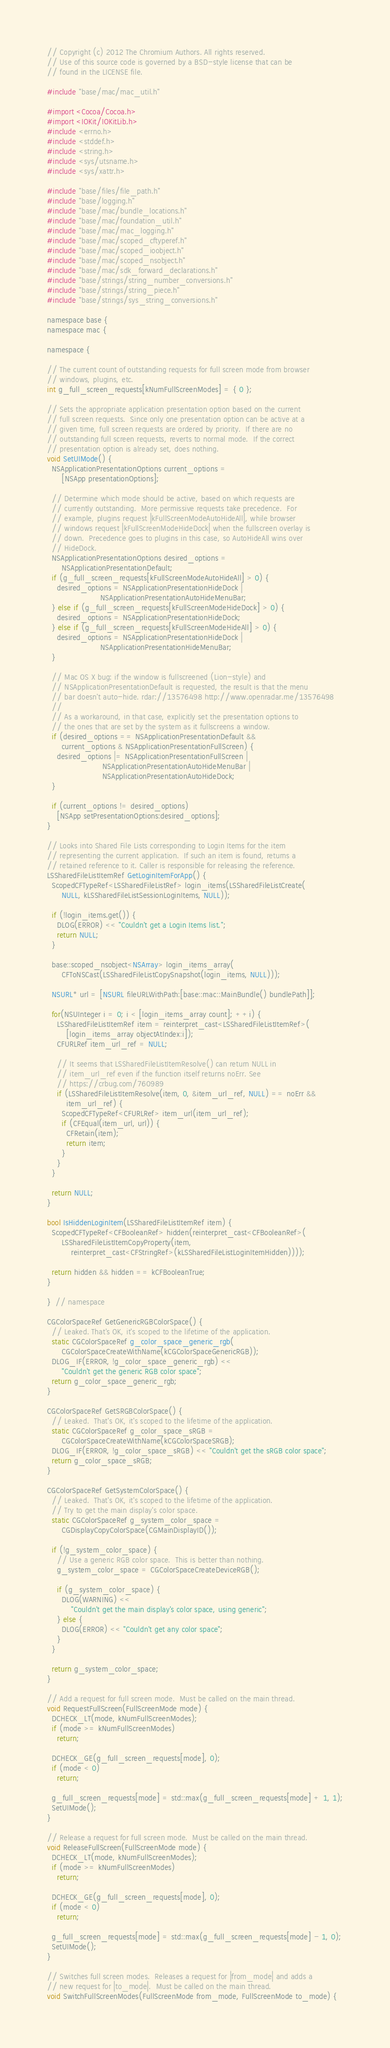Convert code to text. <code><loc_0><loc_0><loc_500><loc_500><_ObjectiveC_>// Copyright (c) 2012 The Chromium Authors. All rights reserved.
// Use of this source code is governed by a BSD-style license that can be
// found in the LICENSE file.

#include "base/mac/mac_util.h"

#import <Cocoa/Cocoa.h>
#import <IOKit/IOKitLib.h>
#include <errno.h>
#include <stddef.h>
#include <string.h>
#include <sys/utsname.h>
#include <sys/xattr.h>

#include "base/files/file_path.h"
#include "base/logging.h"
#include "base/mac/bundle_locations.h"
#include "base/mac/foundation_util.h"
#include "base/mac/mac_logging.h"
#include "base/mac/scoped_cftyperef.h"
#include "base/mac/scoped_ioobject.h"
#include "base/mac/scoped_nsobject.h"
#include "base/mac/sdk_forward_declarations.h"
#include "base/strings/string_number_conversions.h"
#include "base/strings/string_piece.h"
#include "base/strings/sys_string_conversions.h"

namespace base {
namespace mac {

namespace {

// The current count of outstanding requests for full screen mode from browser
// windows, plugins, etc.
int g_full_screen_requests[kNumFullScreenModes] = { 0 };

// Sets the appropriate application presentation option based on the current
// full screen requests.  Since only one presentation option can be active at a
// given time, full screen requests are ordered by priority.  If there are no
// outstanding full screen requests, reverts to normal mode.  If the correct
// presentation option is already set, does nothing.
void SetUIMode() {
  NSApplicationPresentationOptions current_options =
      [NSApp presentationOptions];

  // Determine which mode should be active, based on which requests are
  // currently outstanding.  More permissive requests take precedence.  For
  // example, plugins request |kFullScreenModeAutoHideAll|, while browser
  // windows request |kFullScreenModeHideDock| when the fullscreen overlay is
  // down.  Precedence goes to plugins in this case, so AutoHideAll wins over
  // HideDock.
  NSApplicationPresentationOptions desired_options =
      NSApplicationPresentationDefault;
  if (g_full_screen_requests[kFullScreenModeAutoHideAll] > 0) {
    desired_options = NSApplicationPresentationHideDock |
                      NSApplicationPresentationAutoHideMenuBar;
  } else if (g_full_screen_requests[kFullScreenModeHideDock] > 0) {
    desired_options = NSApplicationPresentationHideDock;
  } else if (g_full_screen_requests[kFullScreenModeHideAll] > 0) {
    desired_options = NSApplicationPresentationHideDock |
                      NSApplicationPresentationHideMenuBar;
  }

  // Mac OS X bug: if the window is fullscreened (Lion-style) and
  // NSApplicationPresentationDefault is requested, the result is that the menu
  // bar doesn't auto-hide. rdar://13576498 http://www.openradar.me/13576498
  //
  // As a workaround, in that case, explicitly set the presentation options to
  // the ones that are set by the system as it fullscreens a window.
  if (desired_options == NSApplicationPresentationDefault &&
      current_options & NSApplicationPresentationFullScreen) {
    desired_options |= NSApplicationPresentationFullScreen |
                       NSApplicationPresentationAutoHideMenuBar |
                       NSApplicationPresentationAutoHideDock;
  }

  if (current_options != desired_options)
    [NSApp setPresentationOptions:desired_options];
}

// Looks into Shared File Lists corresponding to Login Items for the item
// representing the current application.  If such an item is found, returns a
// retained reference to it. Caller is responsible for releasing the reference.
LSSharedFileListItemRef GetLoginItemForApp() {
  ScopedCFTypeRef<LSSharedFileListRef> login_items(LSSharedFileListCreate(
      NULL, kLSSharedFileListSessionLoginItems, NULL));

  if (!login_items.get()) {
    DLOG(ERROR) << "Couldn't get a Login Items list.";
    return NULL;
  }

  base::scoped_nsobject<NSArray> login_items_array(
      CFToNSCast(LSSharedFileListCopySnapshot(login_items, NULL)));

  NSURL* url = [NSURL fileURLWithPath:[base::mac::MainBundle() bundlePath]];

  for(NSUInteger i = 0; i < [login_items_array count]; ++i) {
    LSSharedFileListItemRef item = reinterpret_cast<LSSharedFileListItemRef>(
        [login_items_array objectAtIndex:i]);
    CFURLRef item_url_ref = NULL;

    // It seems that LSSharedFileListItemResolve() can return NULL in
    // item_url_ref even if the function itself returns noErr. See
    // https://crbug.com/760989
    if (LSSharedFileListItemResolve(item, 0, &item_url_ref, NULL) == noErr &&
        item_url_ref) {
      ScopedCFTypeRef<CFURLRef> item_url(item_url_ref);
      if (CFEqual(item_url, url)) {
        CFRetain(item);
        return item;
      }
    }
  }

  return NULL;
}

bool IsHiddenLoginItem(LSSharedFileListItemRef item) {
  ScopedCFTypeRef<CFBooleanRef> hidden(reinterpret_cast<CFBooleanRef>(
      LSSharedFileListItemCopyProperty(item,
          reinterpret_cast<CFStringRef>(kLSSharedFileListLoginItemHidden))));

  return hidden && hidden == kCFBooleanTrue;
}

}  // namespace

CGColorSpaceRef GetGenericRGBColorSpace() {
  // Leaked. That's OK, it's scoped to the lifetime of the application.
  static CGColorSpaceRef g_color_space_generic_rgb(
      CGColorSpaceCreateWithName(kCGColorSpaceGenericRGB));
  DLOG_IF(ERROR, !g_color_space_generic_rgb) <<
      "Couldn't get the generic RGB color space";
  return g_color_space_generic_rgb;
}

CGColorSpaceRef GetSRGBColorSpace() {
  // Leaked.  That's OK, it's scoped to the lifetime of the application.
  static CGColorSpaceRef g_color_space_sRGB =
      CGColorSpaceCreateWithName(kCGColorSpaceSRGB);
  DLOG_IF(ERROR, !g_color_space_sRGB) << "Couldn't get the sRGB color space";
  return g_color_space_sRGB;
}

CGColorSpaceRef GetSystemColorSpace() {
  // Leaked.  That's OK, it's scoped to the lifetime of the application.
  // Try to get the main display's color space.
  static CGColorSpaceRef g_system_color_space =
      CGDisplayCopyColorSpace(CGMainDisplayID());

  if (!g_system_color_space) {
    // Use a generic RGB color space.  This is better than nothing.
    g_system_color_space = CGColorSpaceCreateDeviceRGB();

    if (g_system_color_space) {
      DLOG(WARNING) <<
          "Couldn't get the main display's color space, using generic";
    } else {
      DLOG(ERROR) << "Couldn't get any color space";
    }
  }

  return g_system_color_space;
}

// Add a request for full screen mode.  Must be called on the main thread.
void RequestFullScreen(FullScreenMode mode) {
  DCHECK_LT(mode, kNumFullScreenModes);
  if (mode >= kNumFullScreenModes)
    return;

  DCHECK_GE(g_full_screen_requests[mode], 0);
  if (mode < 0)
    return;

  g_full_screen_requests[mode] = std::max(g_full_screen_requests[mode] + 1, 1);
  SetUIMode();
}

// Release a request for full screen mode.  Must be called on the main thread.
void ReleaseFullScreen(FullScreenMode mode) {
  DCHECK_LT(mode, kNumFullScreenModes);
  if (mode >= kNumFullScreenModes)
    return;

  DCHECK_GE(g_full_screen_requests[mode], 0);
  if (mode < 0)
    return;

  g_full_screen_requests[mode] = std::max(g_full_screen_requests[mode] - 1, 0);
  SetUIMode();
}

// Switches full screen modes.  Releases a request for |from_mode| and adds a
// new request for |to_mode|.  Must be called on the main thread.
void SwitchFullScreenModes(FullScreenMode from_mode, FullScreenMode to_mode) {</code> 